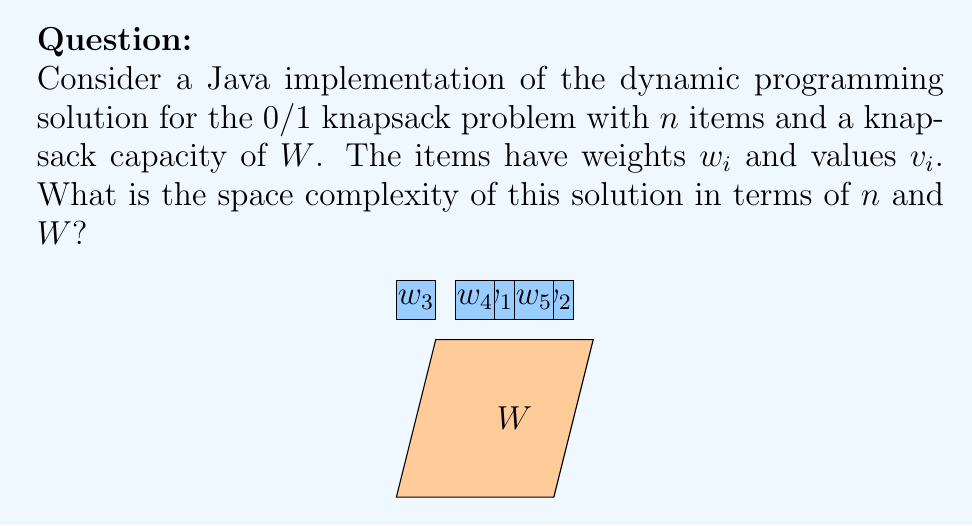Could you help me with this problem? To determine the space complexity of the dynamic programming solution for the 0/1 knapsack problem, we need to analyze the data structures used in the implementation:

1. The dynamic programming solution typically uses a 2D array (or table) to store intermediate results.

2. The dimensions of this array are determined by:
   - The number of items ($n$)
   - The capacity of the knapsack ($W$)

3. The table dimensions are $(n+1) \times (W+1)$, where:
   - Rows represent the items (0 to $n$)
   - Columns represent the weights (0 to $W$)

4. Each cell in the table stores a single integer value, representing the maximum value achievable for the corresponding subproblem.

5. In Java, an integer typically occupies 4 bytes of memory.

6. Therefore, the total space required for the DP table is:
   $$(n+1) \times (W+1) \times 4$$ bytes

7. Simplifying, we get:
   $$4nW + 4n + 4W + 4$$ bytes

8. In big O notation, we consider the dominant terms and ignore constants. The dominant term here is $nW$.

9. Additional space is required for input arrays (weights and values), but these are typically $O(n)$ and do not affect the overall space complexity.

Therefore, the space complexity of the dynamic programming solution for the 0/1 knapsack problem is $O(nW)$.
Answer: $O(nW)$ 